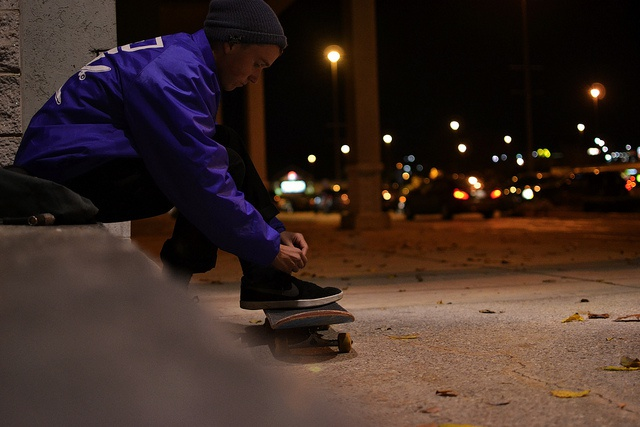Describe the objects in this image and their specific colors. I can see people in black, navy, darkblue, and maroon tones, bench in black, maroon, and brown tones, backpack in black, gray, and maroon tones, skateboard in black, maroon, and gray tones, and car in black, maroon, gray, and red tones in this image. 